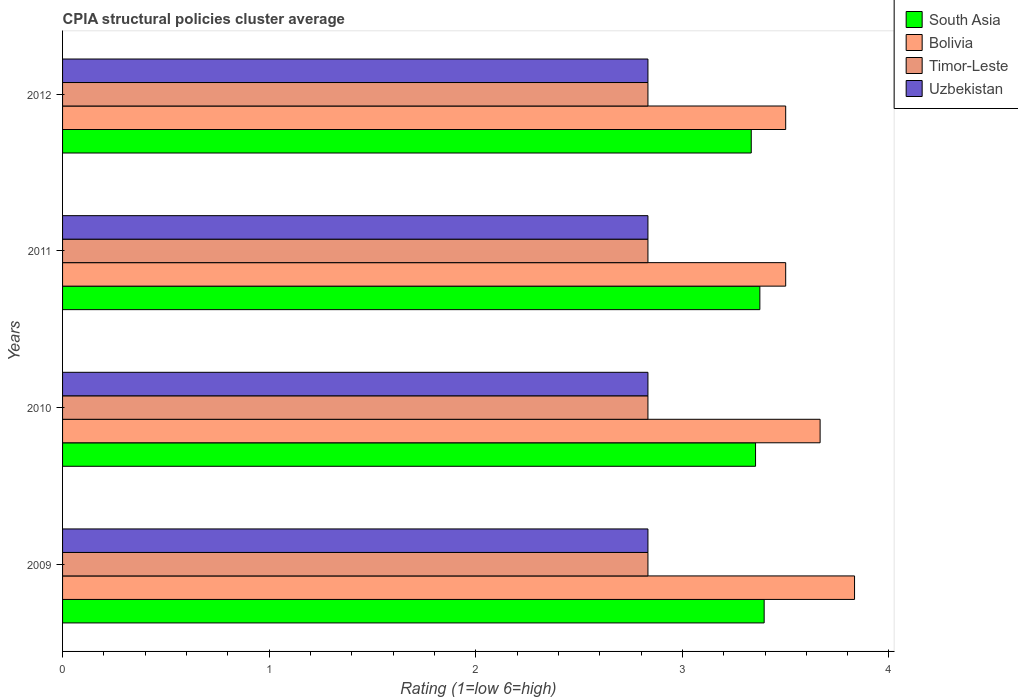Are the number of bars per tick equal to the number of legend labels?
Offer a very short reply. Yes. How many bars are there on the 2nd tick from the top?
Keep it short and to the point. 4. How many bars are there on the 2nd tick from the bottom?
Offer a terse response. 4. What is the label of the 4th group of bars from the top?
Your answer should be very brief. 2009. What is the CPIA rating in South Asia in 2010?
Provide a succinct answer. 3.35. Across all years, what is the maximum CPIA rating in Timor-Leste?
Keep it short and to the point. 2.83. Across all years, what is the minimum CPIA rating in Bolivia?
Your response must be concise. 3.5. What is the total CPIA rating in South Asia in the graph?
Provide a succinct answer. 13.46. What is the difference between the CPIA rating in South Asia in 2010 and that in 2012?
Keep it short and to the point. 0.02. What is the average CPIA rating in South Asia per year?
Your answer should be compact. 3.36. In the year 2011, what is the difference between the CPIA rating in Uzbekistan and CPIA rating in South Asia?
Your response must be concise. -0.54. What is the ratio of the CPIA rating in Bolivia in 2010 to that in 2012?
Offer a terse response. 1.05. Is the CPIA rating in Timor-Leste in 2009 less than that in 2010?
Make the answer very short. No. Is the difference between the CPIA rating in Uzbekistan in 2009 and 2011 greater than the difference between the CPIA rating in South Asia in 2009 and 2011?
Ensure brevity in your answer.  No. What is the difference between the highest and the second highest CPIA rating in South Asia?
Keep it short and to the point. 0.02. What is the difference between the highest and the lowest CPIA rating in Bolivia?
Your answer should be compact. 0.33. Is the sum of the CPIA rating in South Asia in 2010 and 2011 greater than the maximum CPIA rating in Bolivia across all years?
Provide a short and direct response. Yes. What does the 3rd bar from the top in 2012 represents?
Give a very brief answer. Bolivia. Is it the case that in every year, the sum of the CPIA rating in South Asia and CPIA rating in Bolivia is greater than the CPIA rating in Timor-Leste?
Your answer should be compact. Yes. Are the values on the major ticks of X-axis written in scientific E-notation?
Your answer should be compact. No. Does the graph contain grids?
Offer a very short reply. No. Where does the legend appear in the graph?
Make the answer very short. Top right. What is the title of the graph?
Give a very brief answer. CPIA structural policies cluster average. Does "Bermuda" appear as one of the legend labels in the graph?
Give a very brief answer. No. What is the label or title of the Y-axis?
Offer a very short reply. Years. What is the Rating (1=low 6=high) of South Asia in 2009?
Your answer should be very brief. 3.4. What is the Rating (1=low 6=high) in Bolivia in 2009?
Your answer should be compact. 3.83. What is the Rating (1=low 6=high) of Timor-Leste in 2009?
Offer a very short reply. 2.83. What is the Rating (1=low 6=high) of Uzbekistan in 2009?
Make the answer very short. 2.83. What is the Rating (1=low 6=high) in South Asia in 2010?
Ensure brevity in your answer.  3.35. What is the Rating (1=low 6=high) of Bolivia in 2010?
Ensure brevity in your answer.  3.67. What is the Rating (1=low 6=high) in Timor-Leste in 2010?
Give a very brief answer. 2.83. What is the Rating (1=low 6=high) of Uzbekistan in 2010?
Give a very brief answer. 2.83. What is the Rating (1=low 6=high) of South Asia in 2011?
Provide a succinct answer. 3.38. What is the Rating (1=low 6=high) of Timor-Leste in 2011?
Ensure brevity in your answer.  2.83. What is the Rating (1=low 6=high) of Uzbekistan in 2011?
Make the answer very short. 2.83. What is the Rating (1=low 6=high) of South Asia in 2012?
Offer a terse response. 3.33. What is the Rating (1=low 6=high) in Timor-Leste in 2012?
Make the answer very short. 2.83. What is the Rating (1=low 6=high) of Uzbekistan in 2012?
Keep it short and to the point. 2.83. Across all years, what is the maximum Rating (1=low 6=high) in South Asia?
Keep it short and to the point. 3.4. Across all years, what is the maximum Rating (1=low 6=high) of Bolivia?
Provide a succinct answer. 3.83. Across all years, what is the maximum Rating (1=low 6=high) of Timor-Leste?
Offer a terse response. 2.83. Across all years, what is the maximum Rating (1=low 6=high) in Uzbekistan?
Your answer should be compact. 2.83. Across all years, what is the minimum Rating (1=low 6=high) in South Asia?
Provide a short and direct response. 3.33. Across all years, what is the minimum Rating (1=low 6=high) of Bolivia?
Keep it short and to the point. 3.5. Across all years, what is the minimum Rating (1=low 6=high) in Timor-Leste?
Make the answer very short. 2.83. Across all years, what is the minimum Rating (1=low 6=high) in Uzbekistan?
Provide a succinct answer. 2.83. What is the total Rating (1=low 6=high) of South Asia in the graph?
Offer a very short reply. 13.46. What is the total Rating (1=low 6=high) in Bolivia in the graph?
Offer a terse response. 14.5. What is the total Rating (1=low 6=high) of Timor-Leste in the graph?
Provide a succinct answer. 11.33. What is the total Rating (1=low 6=high) in Uzbekistan in the graph?
Your answer should be compact. 11.33. What is the difference between the Rating (1=low 6=high) of South Asia in 2009 and that in 2010?
Provide a short and direct response. 0.04. What is the difference between the Rating (1=low 6=high) of Timor-Leste in 2009 and that in 2010?
Offer a very short reply. 0. What is the difference between the Rating (1=low 6=high) of South Asia in 2009 and that in 2011?
Keep it short and to the point. 0.02. What is the difference between the Rating (1=low 6=high) of Bolivia in 2009 and that in 2011?
Ensure brevity in your answer.  0.33. What is the difference between the Rating (1=low 6=high) in Timor-Leste in 2009 and that in 2011?
Offer a very short reply. 0. What is the difference between the Rating (1=low 6=high) of South Asia in 2009 and that in 2012?
Ensure brevity in your answer.  0.06. What is the difference between the Rating (1=low 6=high) in Bolivia in 2009 and that in 2012?
Make the answer very short. 0.33. What is the difference between the Rating (1=low 6=high) in South Asia in 2010 and that in 2011?
Your answer should be very brief. -0.02. What is the difference between the Rating (1=low 6=high) of Bolivia in 2010 and that in 2011?
Make the answer very short. 0.17. What is the difference between the Rating (1=low 6=high) in Timor-Leste in 2010 and that in 2011?
Your response must be concise. 0. What is the difference between the Rating (1=low 6=high) of Uzbekistan in 2010 and that in 2011?
Provide a short and direct response. 0. What is the difference between the Rating (1=low 6=high) in South Asia in 2010 and that in 2012?
Give a very brief answer. 0.02. What is the difference between the Rating (1=low 6=high) of Bolivia in 2010 and that in 2012?
Make the answer very short. 0.17. What is the difference between the Rating (1=low 6=high) of Uzbekistan in 2010 and that in 2012?
Make the answer very short. 0. What is the difference between the Rating (1=low 6=high) in South Asia in 2011 and that in 2012?
Your response must be concise. 0.04. What is the difference between the Rating (1=low 6=high) of South Asia in 2009 and the Rating (1=low 6=high) of Bolivia in 2010?
Give a very brief answer. -0.27. What is the difference between the Rating (1=low 6=high) of South Asia in 2009 and the Rating (1=low 6=high) of Timor-Leste in 2010?
Offer a terse response. 0.56. What is the difference between the Rating (1=low 6=high) of South Asia in 2009 and the Rating (1=low 6=high) of Uzbekistan in 2010?
Provide a succinct answer. 0.56. What is the difference between the Rating (1=low 6=high) of South Asia in 2009 and the Rating (1=low 6=high) of Bolivia in 2011?
Offer a terse response. -0.1. What is the difference between the Rating (1=low 6=high) of South Asia in 2009 and the Rating (1=low 6=high) of Timor-Leste in 2011?
Provide a short and direct response. 0.56. What is the difference between the Rating (1=low 6=high) of South Asia in 2009 and the Rating (1=low 6=high) of Uzbekistan in 2011?
Keep it short and to the point. 0.56. What is the difference between the Rating (1=low 6=high) in Bolivia in 2009 and the Rating (1=low 6=high) in Timor-Leste in 2011?
Ensure brevity in your answer.  1. What is the difference between the Rating (1=low 6=high) of Bolivia in 2009 and the Rating (1=low 6=high) of Uzbekistan in 2011?
Provide a short and direct response. 1. What is the difference between the Rating (1=low 6=high) in Timor-Leste in 2009 and the Rating (1=low 6=high) in Uzbekistan in 2011?
Your answer should be compact. 0. What is the difference between the Rating (1=low 6=high) in South Asia in 2009 and the Rating (1=low 6=high) in Bolivia in 2012?
Your answer should be very brief. -0.1. What is the difference between the Rating (1=low 6=high) in South Asia in 2009 and the Rating (1=low 6=high) in Timor-Leste in 2012?
Keep it short and to the point. 0.56. What is the difference between the Rating (1=low 6=high) in South Asia in 2009 and the Rating (1=low 6=high) in Uzbekistan in 2012?
Your response must be concise. 0.56. What is the difference between the Rating (1=low 6=high) of Bolivia in 2009 and the Rating (1=low 6=high) of Timor-Leste in 2012?
Offer a terse response. 1. What is the difference between the Rating (1=low 6=high) of Timor-Leste in 2009 and the Rating (1=low 6=high) of Uzbekistan in 2012?
Offer a very short reply. 0. What is the difference between the Rating (1=low 6=high) in South Asia in 2010 and the Rating (1=low 6=high) in Bolivia in 2011?
Offer a terse response. -0.15. What is the difference between the Rating (1=low 6=high) of South Asia in 2010 and the Rating (1=low 6=high) of Timor-Leste in 2011?
Provide a short and direct response. 0.52. What is the difference between the Rating (1=low 6=high) of South Asia in 2010 and the Rating (1=low 6=high) of Uzbekistan in 2011?
Provide a short and direct response. 0.52. What is the difference between the Rating (1=low 6=high) in Bolivia in 2010 and the Rating (1=low 6=high) in Timor-Leste in 2011?
Your answer should be very brief. 0.83. What is the difference between the Rating (1=low 6=high) of Bolivia in 2010 and the Rating (1=low 6=high) of Uzbekistan in 2011?
Make the answer very short. 0.83. What is the difference between the Rating (1=low 6=high) of Timor-Leste in 2010 and the Rating (1=low 6=high) of Uzbekistan in 2011?
Your response must be concise. 0. What is the difference between the Rating (1=low 6=high) in South Asia in 2010 and the Rating (1=low 6=high) in Bolivia in 2012?
Ensure brevity in your answer.  -0.15. What is the difference between the Rating (1=low 6=high) in South Asia in 2010 and the Rating (1=low 6=high) in Timor-Leste in 2012?
Provide a succinct answer. 0.52. What is the difference between the Rating (1=low 6=high) in South Asia in 2010 and the Rating (1=low 6=high) in Uzbekistan in 2012?
Ensure brevity in your answer.  0.52. What is the difference between the Rating (1=low 6=high) in Bolivia in 2010 and the Rating (1=low 6=high) in Uzbekistan in 2012?
Offer a terse response. 0.83. What is the difference between the Rating (1=low 6=high) of South Asia in 2011 and the Rating (1=low 6=high) of Bolivia in 2012?
Offer a terse response. -0.12. What is the difference between the Rating (1=low 6=high) of South Asia in 2011 and the Rating (1=low 6=high) of Timor-Leste in 2012?
Give a very brief answer. 0.54. What is the difference between the Rating (1=low 6=high) of South Asia in 2011 and the Rating (1=low 6=high) of Uzbekistan in 2012?
Your response must be concise. 0.54. What is the average Rating (1=low 6=high) in South Asia per year?
Offer a terse response. 3.36. What is the average Rating (1=low 6=high) of Bolivia per year?
Make the answer very short. 3.62. What is the average Rating (1=low 6=high) of Timor-Leste per year?
Your response must be concise. 2.83. What is the average Rating (1=low 6=high) in Uzbekistan per year?
Keep it short and to the point. 2.83. In the year 2009, what is the difference between the Rating (1=low 6=high) in South Asia and Rating (1=low 6=high) in Bolivia?
Keep it short and to the point. -0.44. In the year 2009, what is the difference between the Rating (1=low 6=high) of South Asia and Rating (1=low 6=high) of Timor-Leste?
Make the answer very short. 0.56. In the year 2009, what is the difference between the Rating (1=low 6=high) in South Asia and Rating (1=low 6=high) in Uzbekistan?
Provide a short and direct response. 0.56. In the year 2009, what is the difference between the Rating (1=low 6=high) of Bolivia and Rating (1=low 6=high) of Timor-Leste?
Offer a terse response. 1. In the year 2009, what is the difference between the Rating (1=low 6=high) in Timor-Leste and Rating (1=low 6=high) in Uzbekistan?
Your answer should be compact. 0. In the year 2010, what is the difference between the Rating (1=low 6=high) in South Asia and Rating (1=low 6=high) in Bolivia?
Your response must be concise. -0.31. In the year 2010, what is the difference between the Rating (1=low 6=high) of South Asia and Rating (1=low 6=high) of Timor-Leste?
Offer a terse response. 0.52. In the year 2010, what is the difference between the Rating (1=low 6=high) in South Asia and Rating (1=low 6=high) in Uzbekistan?
Give a very brief answer. 0.52. In the year 2010, what is the difference between the Rating (1=low 6=high) of Bolivia and Rating (1=low 6=high) of Timor-Leste?
Your answer should be compact. 0.83. In the year 2010, what is the difference between the Rating (1=low 6=high) of Bolivia and Rating (1=low 6=high) of Uzbekistan?
Keep it short and to the point. 0.83. In the year 2010, what is the difference between the Rating (1=low 6=high) in Timor-Leste and Rating (1=low 6=high) in Uzbekistan?
Keep it short and to the point. 0. In the year 2011, what is the difference between the Rating (1=low 6=high) in South Asia and Rating (1=low 6=high) in Bolivia?
Keep it short and to the point. -0.12. In the year 2011, what is the difference between the Rating (1=low 6=high) of South Asia and Rating (1=low 6=high) of Timor-Leste?
Offer a terse response. 0.54. In the year 2011, what is the difference between the Rating (1=low 6=high) of South Asia and Rating (1=low 6=high) of Uzbekistan?
Offer a terse response. 0.54. In the year 2011, what is the difference between the Rating (1=low 6=high) in Timor-Leste and Rating (1=low 6=high) in Uzbekistan?
Give a very brief answer. 0. In the year 2012, what is the difference between the Rating (1=low 6=high) of South Asia and Rating (1=low 6=high) of Bolivia?
Your answer should be very brief. -0.17. In the year 2012, what is the difference between the Rating (1=low 6=high) of South Asia and Rating (1=low 6=high) of Timor-Leste?
Provide a short and direct response. 0.5. In the year 2012, what is the difference between the Rating (1=low 6=high) in Bolivia and Rating (1=low 6=high) in Timor-Leste?
Your answer should be very brief. 0.67. In the year 2012, what is the difference between the Rating (1=low 6=high) in Bolivia and Rating (1=low 6=high) in Uzbekistan?
Offer a very short reply. 0.67. In the year 2012, what is the difference between the Rating (1=low 6=high) in Timor-Leste and Rating (1=low 6=high) in Uzbekistan?
Make the answer very short. 0. What is the ratio of the Rating (1=low 6=high) of South Asia in 2009 to that in 2010?
Offer a very short reply. 1.01. What is the ratio of the Rating (1=low 6=high) of Bolivia in 2009 to that in 2010?
Give a very brief answer. 1.05. What is the ratio of the Rating (1=low 6=high) of Timor-Leste in 2009 to that in 2010?
Ensure brevity in your answer.  1. What is the ratio of the Rating (1=low 6=high) in Bolivia in 2009 to that in 2011?
Keep it short and to the point. 1.1. What is the ratio of the Rating (1=low 6=high) in Timor-Leste in 2009 to that in 2011?
Ensure brevity in your answer.  1. What is the ratio of the Rating (1=low 6=high) of South Asia in 2009 to that in 2012?
Your answer should be compact. 1.02. What is the ratio of the Rating (1=low 6=high) of Bolivia in 2009 to that in 2012?
Provide a succinct answer. 1.1. What is the ratio of the Rating (1=low 6=high) in Timor-Leste in 2009 to that in 2012?
Offer a terse response. 1. What is the ratio of the Rating (1=low 6=high) in Bolivia in 2010 to that in 2011?
Provide a short and direct response. 1.05. What is the ratio of the Rating (1=low 6=high) in Timor-Leste in 2010 to that in 2011?
Offer a terse response. 1. What is the ratio of the Rating (1=low 6=high) in Bolivia in 2010 to that in 2012?
Your answer should be very brief. 1.05. What is the ratio of the Rating (1=low 6=high) in Timor-Leste in 2010 to that in 2012?
Provide a short and direct response. 1. What is the ratio of the Rating (1=low 6=high) in South Asia in 2011 to that in 2012?
Ensure brevity in your answer.  1.01. What is the ratio of the Rating (1=low 6=high) of Timor-Leste in 2011 to that in 2012?
Keep it short and to the point. 1. What is the difference between the highest and the second highest Rating (1=low 6=high) in South Asia?
Ensure brevity in your answer.  0.02. What is the difference between the highest and the second highest Rating (1=low 6=high) of Bolivia?
Your answer should be compact. 0.17. What is the difference between the highest and the second highest Rating (1=low 6=high) of Timor-Leste?
Offer a very short reply. 0. What is the difference between the highest and the second highest Rating (1=low 6=high) of Uzbekistan?
Provide a short and direct response. 0. What is the difference between the highest and the lowest Rating (1=low 6=high) of South Asia?
Offer a very short reply. 0.06. What is the difference between the highest and the lowest Rating (1=low 6=high) of Bolivia?
Offer a very short reply. 0.33. What is the difference between the highest and the lowest Rating (1=low 6=high) of Uzbekistan?
Give a very brief answer. 0. 